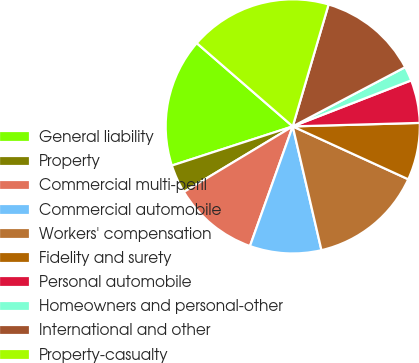Convert chart. <chart><loc_0><loc_0><loc_500><loc_500><pie_chart><fcel>General liability<fcel>Property<fcel>Commercial multi-peril<fcel>Commercial automobile<fcel>Workers' compensation<fcel>Fidelity and surety<fcel>Personal automobile<fcel>Homeowners and personal-other<fcel>International and other<fcel>Property-casualty<nl><fcel>16.36%<fcel>3.64%<fcel>10.91%<fcel>9.09%<fcel>14.54%<fcel>7.27%<fcel>5.46%<fcel>1.82%<fcel>12.73%<fcel>18.18%<nl></chart> 